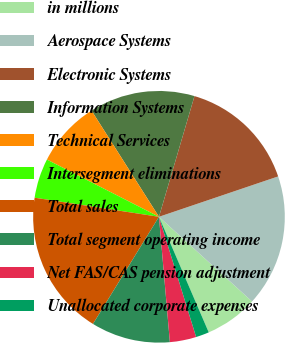<chart> <loc_0><loc_0><loc_500><loc_500><pie_chart><fcel>in millions<fcel>Aerospace Systems<fcel>Electronic Systems<fcel>Information Systems<fcel>Technical Services<fcel>Intersegment eliminations<fcel>Total sales<fcel>Total segment operating income<fcel>Net FAS/CAS pension adjustment<fcel>Unallocated corporate expenses<nl><fcel>6.78%<fcel>16.95%<fcel>15.25%<fcel>13.56%<fcel>8.48%<fcel>5.09%<fcel>18.64%<fcel>10.17%<fcel>3.39%<fcel>1.7%<nl></chart> 